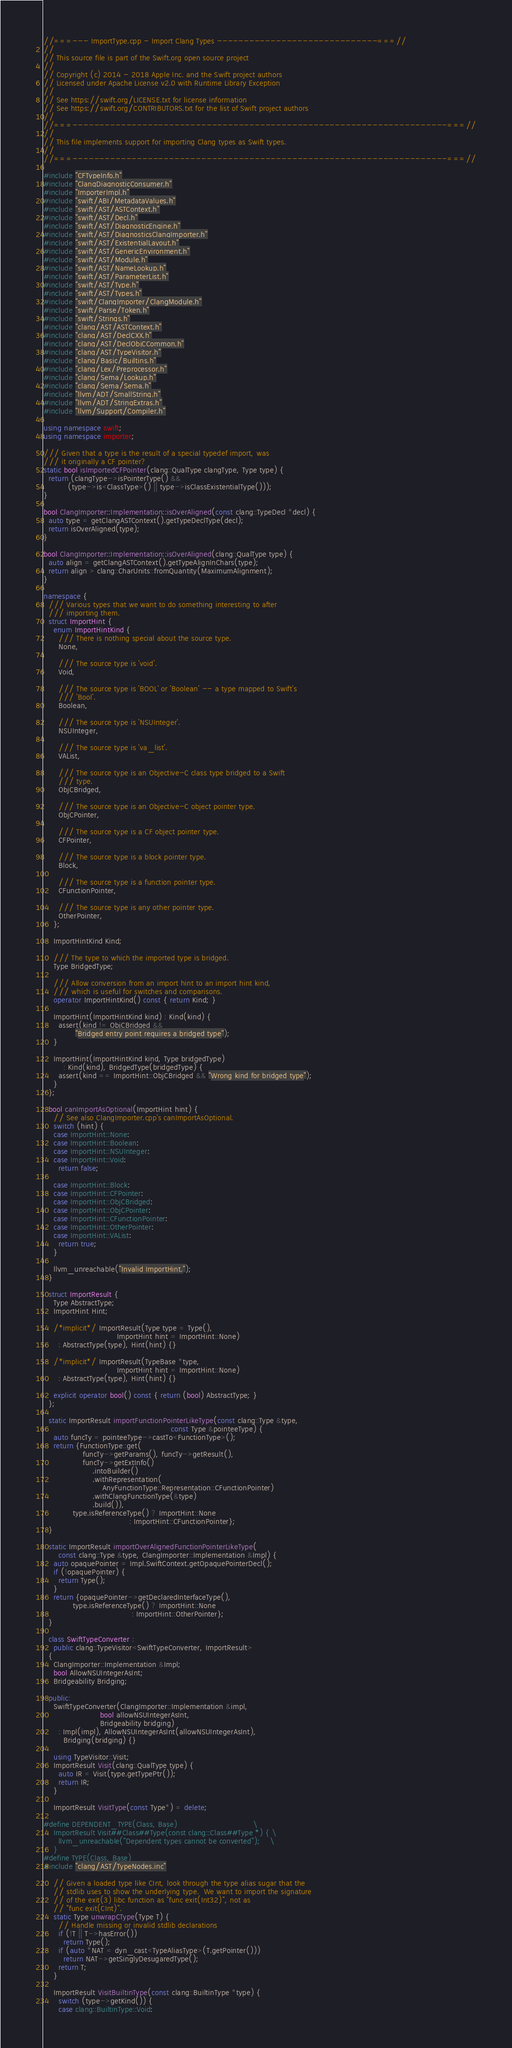Convert code to text. <code><loc_0><loc_0><loc_500><loc_500><_C++_>//===--- ImportType.cpp - Import Clang Types ------------------------------===//
//
// This source file is part of the Swift.org open source project
//
// Copyright (c) 2014 - 2018 Apple Inc. and the Swift project authors
// Licensed under Apache License v2.0 with Runtime Library Exception
//
// See https://swift.org/LICENSE.txt for license information
// See https://swift.org/CONTRIBUTORS.txt for the list of Swift project authors
//
//===----------------------------------------------------------------------===//
//
// This file implements support for importing Clang types as Swift types.
//
//===----------------------------------------------------------------------===//

#include "CFTypeInfo.h"
#include "ClangDiagnosticConsumer.h"
#include "ImporterImpl.h"
#include "swift/ABI/MetadataValues.h"
#include "swift/AST/ASTContext.h"
#include "swift/AST/Decl.h"
#include "swift/AST/DiagnosticEngine.h"
#include "swift/AST/DiagnosticsClangImporter.h"
#include "swift/AST/ExistentialLayout.h"
#include "swift/AST/GenericEnvironment.h"
#include "swift/AST/Module.h"
#include "swift/AST/NameLookup.h"
#include "swift/AST/ParameterList.h"
#include "swift/AST/Type.h"
#include "swift/AST/Types.h"
#include "swift/ClangImporter/ClangModule.h"
#include "swift/Parse/Token.h"
#include "swift/Strings.h"
#include "clang/AST/ASTContext.h"
#include "clang/AST/DeclCXX.h"
#include "clang/AST/DeclObjCCommon.h"
#include "clang/AST/TypeVisitor.h"
#include "clang/Basic/Builtins.h"
#include "clang/Lex/Preprocessor.h"
#include "clang/Sema/Lookup.h"
#include "clang/Sema/Sema.h"
#include "llvm/ADT/SmallString.h"
#include "llvm/ADT/StringExtras.h"
#include "llvm/Support/Compiler.h"

using namespace swift;
using namespace importer;

/// Given that a type is the result of a special typedef import, was
/// it originally a CF pointer?
static bool isImportedCFPointer(clang::QualType clangType, Type type) {
  return (clangType->isPointerType() &&
          (type->is<ClassType>() || type->isClassExistentialType()));
}

bool ClangImporter::Implementation::isOverAligned(const clang::TypeDecl *decl) {
  auto type = getClangASTContext().getTypeDeclType(decl);
  return isOverAligned(type);
}

bool ClangImporter::Implementation::isOverAligned(clang::QualType type) {
  auto align = getClangASTContext().getTypeAlignInChars(type);
  return align > clang::CharUnits::fromQuantity(MaximumAlignment);
}

namespace {
  /// Various types that we want to do something interesting to after
  /// importing them.
  struct ImportHint {
    enum ImportHintKind {
      /// There is nothing special about the source type.
      None,

      /// The source type is 'void'.
      Void,

      /// The source type is 'BOOL' or 'Boolean' -- a type mapped to Swift's
      /// 'Bool'.
      Boolean,

      /// The source type is 'NSUInteger'.
      NSUInteger,

      /// The source type is 'va_list'.
      VAList,

      /// The source type is an Objective-C class type bridged to a Swift
      /// type.
      ObjCBridged,

      /// The source type is an Objective-C object pointer type.
      ObjCPointer,

      /// The source type is a CF object pointer type.
      CFPointer,

      /// The source type is a block pointer type.
      Block,

      /// The source type is a function pointer type.
      CFunctionPointer,

      /// The source type is any other pointer type.
      OtherPointer,
    };

    ImportHintKind Kind;

    /// The type to which the imported type is bridged.
    Type BridgedType;

    /// Allow conversion from an import hint to an import hint kind,
    /// which is useful for switches and comparisons.
    operator ImportHintKind() const { return Kind; }

    ImportHint(ImportHintKind kind) : Kind(kind) {
      assert(kind != ObjCBridged &&
             "Bridged entry point requires a bridged type");
    }

    ImportHint(ImportHintKind kind, Type bridgedType)
        : Kind(kind), BridgedType(bridgedType) {
      assert(kind == ImportHint::ObjCBridged && "Wrong kind for bridged type");
    }
  };

  bool canImportAsOptional(ImportHint hint) {
    // See also ClangImporter.cpp's canImportAsOptional.
    switch (hint) {
    case ImportHint::None:
    case ImportHint::Boolean:
    case ImportHint::NSUInteger:
    case ImportHint::Void:
      return false;

    case ImportHint::Block:
    case ImportHint::CFPointer:
    case ImportHint::ObjCBridged:
    case ImportHint::ObjCPointer:
    case ImportHint::CFunctionPointer:
    case ImportHint::OtherPointer:
    case ImportHint::VAList:
      return true;
    }

    llvm_unreachable("Invalid ImportHint.");
  }

  struct ImportResult {
    Type AbstractType;
    ImportHint Hint;

    /*implicit*/ ImportResult(Type type = Type(),
                              ImportHint hint = ImportHint::None)
      : AbstractType(type), Hint(hint) {}

    /*implicit*/ ImportResult(TypeBase *type,
                              ImportHint hint = ImportHint::None)
      : AbstractType(type), Hint(hint) {}

    explicit operator bool() const { return (bool) AbstractType; }
  };

  static ImportResult importFunctionPointerLikeType(const clang::Type &type,
                                                    const Type &pointeeType) {
    auto funcTy = pointeeType->castTo<FunctionType>();
    return {FunctionType::get(
                funcTy->getParams(), funcTy->getResult(),
                funcTy->getExtInfo()
                    .intoBuilder()
                    .withRepresentation(
                        AnyFunctionType::Representation::CFunctionPointer)
                    .withClangFunctionType(&type)
                    .build()),
            type.isReferenceType() ? ImportHint::None
                                   : ImportHint::CFunctionPointer};
  }

  static ImportResult importOverAlignedFunctionPointerLikeType(
      const clang::Type &type, ClangImporter::Implementation &Impl) {
    auto opaquePointer = Impl.SwiftContext.getOpaquePointerDecl();
    if (!opaquePointer) {
      return Type();
    }
    return {opaquePointer->getDeclaredInterfaceType(),
            type.isReferenceType() ? ImportHint::None
                                    : ImportHint::OtherPointer};
  }

  class SwiftTypeConverter :
    public clang::TypeVisitor<SwiftTypeConverter, ImportResult>
  {
    ClangImporter::Implementation &Impl;
    bool AllowNSUIntegerAsInt;
    Bridgeability Bridging;

  public:
    SwiftTypeConverter(ClangImporter::Implementation &impl,
                       bool allowNSUIntegerAsInt,
                       Bridgeability bridging)
      : Impl(impl), AllowNSUIntegerAsInt(allowNSUIntegerAsInt),
        Bridging(bridging) {}

    using TypeVisitor::Visit;
    ImportResult Visit(clang::QualType type) {
      auto IR = Visit(type.getTypePtr());
      return IR;
    }

    ImportResult VisitType(const Type*) = delete;

#define DEPENDENT_TYPE(Class, Base)                               \
    ImportResult Visit##Class##Type(const clang::Class##Type *) { \
      llvm_unreachable("Dependent types cannot be converted");    \
    }
#define TYPE(Class, Base)
#include "clang/AST/TypeNodes.inc"

    // Given a loaded type like CInt, look through the type alias sugar that the
    // stdlib uses to show the underlying type.  We want to import the signature
    // of the exit(3) libc function as "func exit(Int32)", not as
    // "func exit(CInt)".
    static Type unwrapCType(Type T) {
      // Handle missing or invalid stdlib declarations
      if (!T || T->hasError())
        return Type();
      if (auto *NAT = dyn_cast<TypeAliasType>(T.getPointer()))
        return NAT->getSinglyDesugaredType();
      return T;
    }
    
    ImportResult VisitBuiltinType(const clang::BuiltinType *type) {
      switch (type->getKind()) {
      case clang::BuiltinType::Void:</code> 